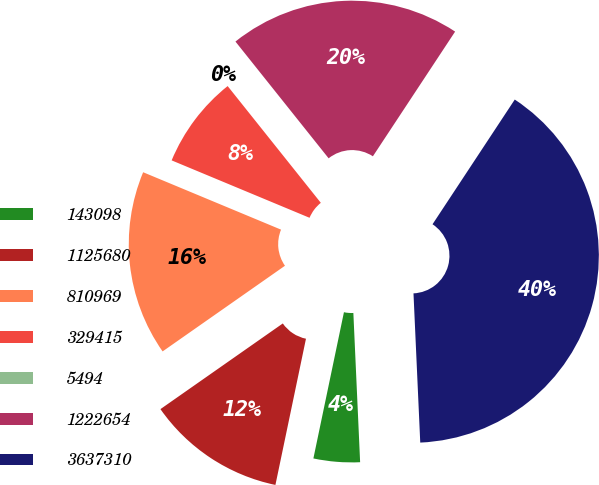Convert chart to OTSL. <chart><loc_0><loc_0><loc_500><loc_500><pie_chart><fcel>143098<fcel>1125680<fcel>810969<fcel>329415<fcel>5494<fcel>1222654<fcel>3637310<nl><fcel>4.0%<fcel>12.0%<fcel>16.0%<fcel>8.0%<fcel>0.0%<fcel>20.0%<fcel>40.0%<nl></chart> 